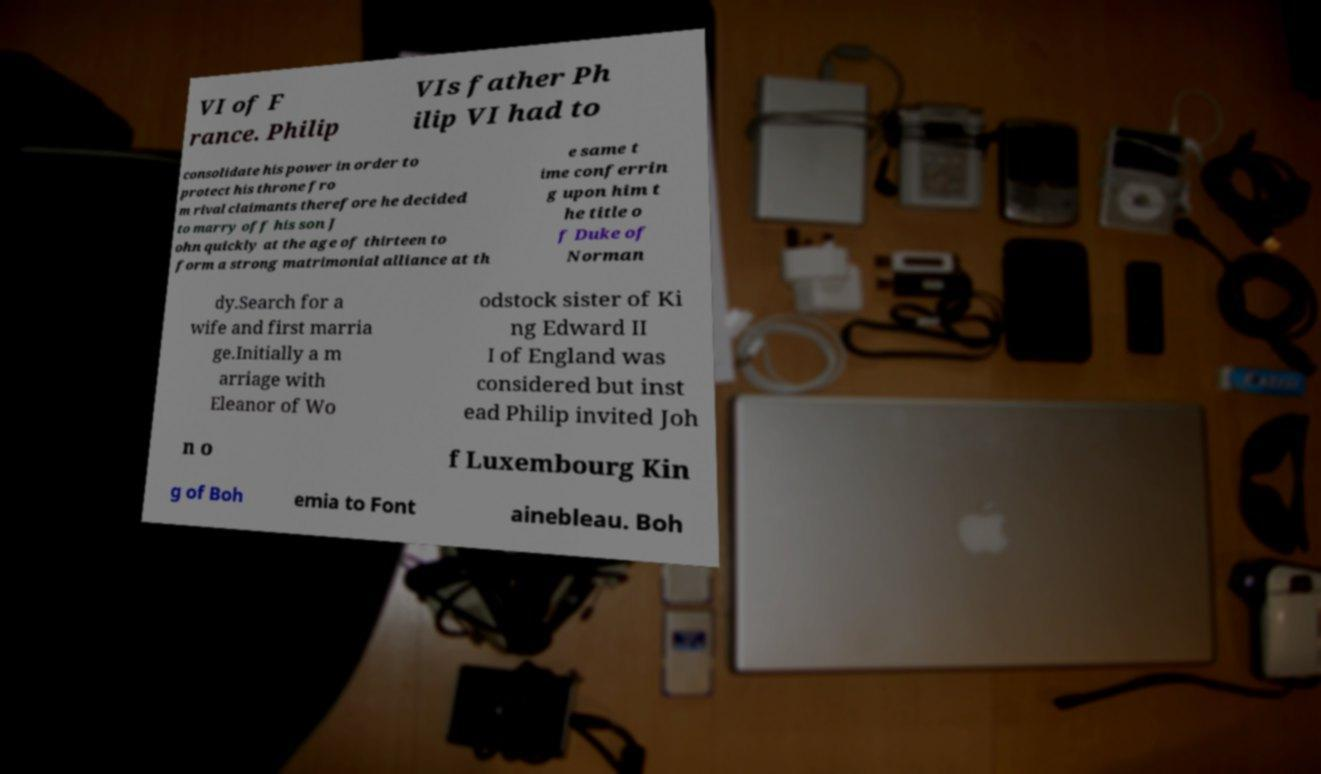Can you accurately transcribe the text from the provided image for me? VI of F rance. Philip VIs father Ph ilip VI had to consolidate his power in order to protect his throne fro m rival claimants therefore he decided to marry off his son J ohn quickly at the age of thirteen to form a strong matrimonial alliance at th e same t ime conferrin g upon him t he title o f Duke of Norman dy.Search for a wife and first marria ge.Initially a m arriage with Eleanor of Wo odstock sister of Ki ng Edward II I of England was considered but inst ead Philip invited Joh n o f Luxembourg Kin g of Boh emia to Font ainebleau. Boh 